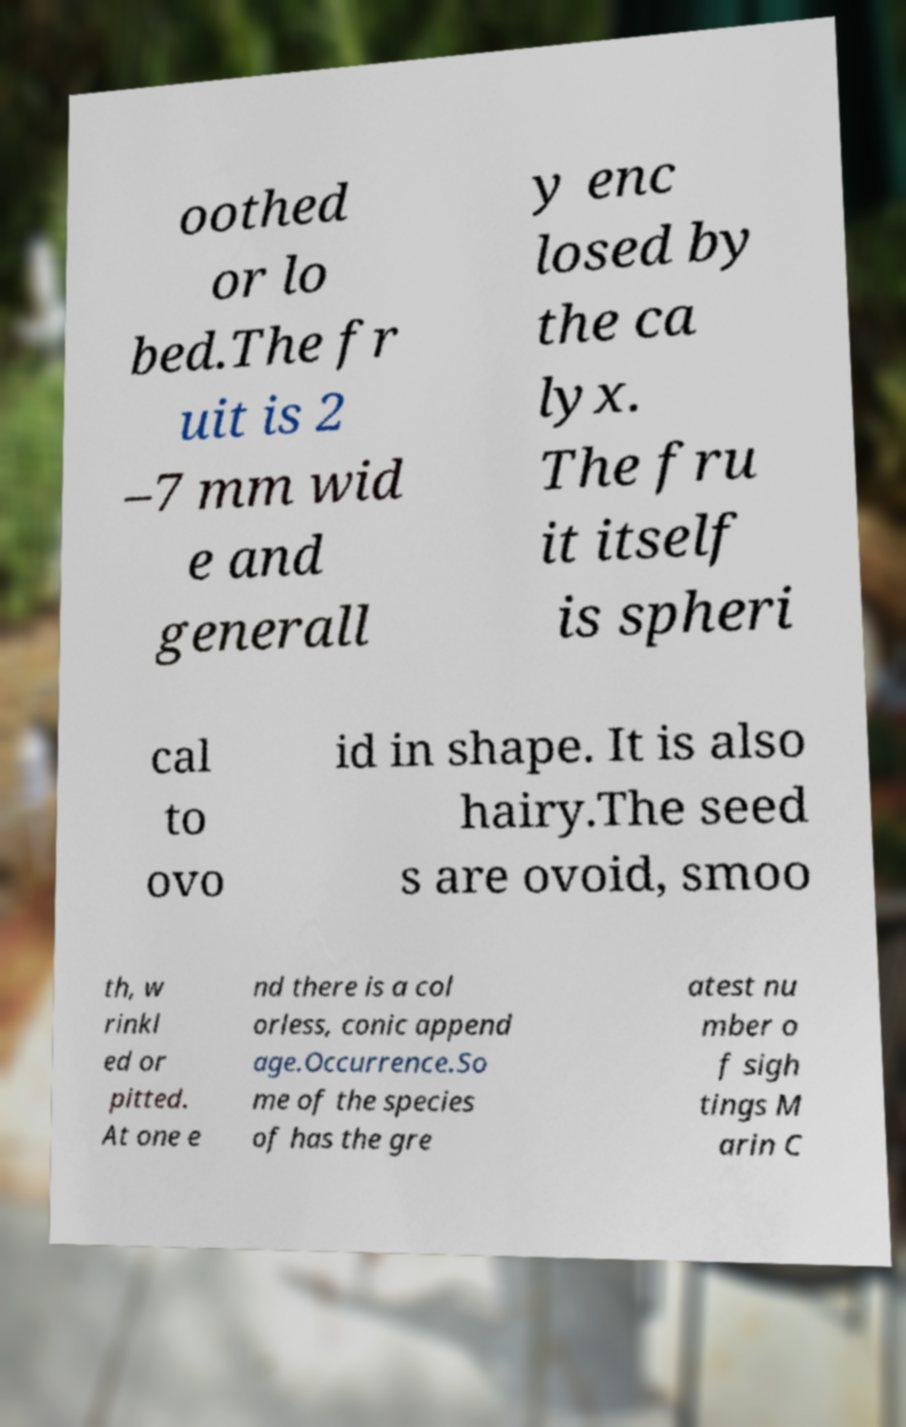For documentation purposes, I need the text within this image transcribed. Could you provide that? oothed or lo bed.The fr uit is 2 –7 mm wid e and generall y enc losed by the ca lyx. The fru it itself is spheri cal to ovo id in shape. It is also hairy.The seed s are ovoid, smoo th, w rinkl ed or pitted. At one e nd there is a col orless, conic append age.Occurrence.So me of the species of has the gre atest nu mber o f sigh tings M arin C 